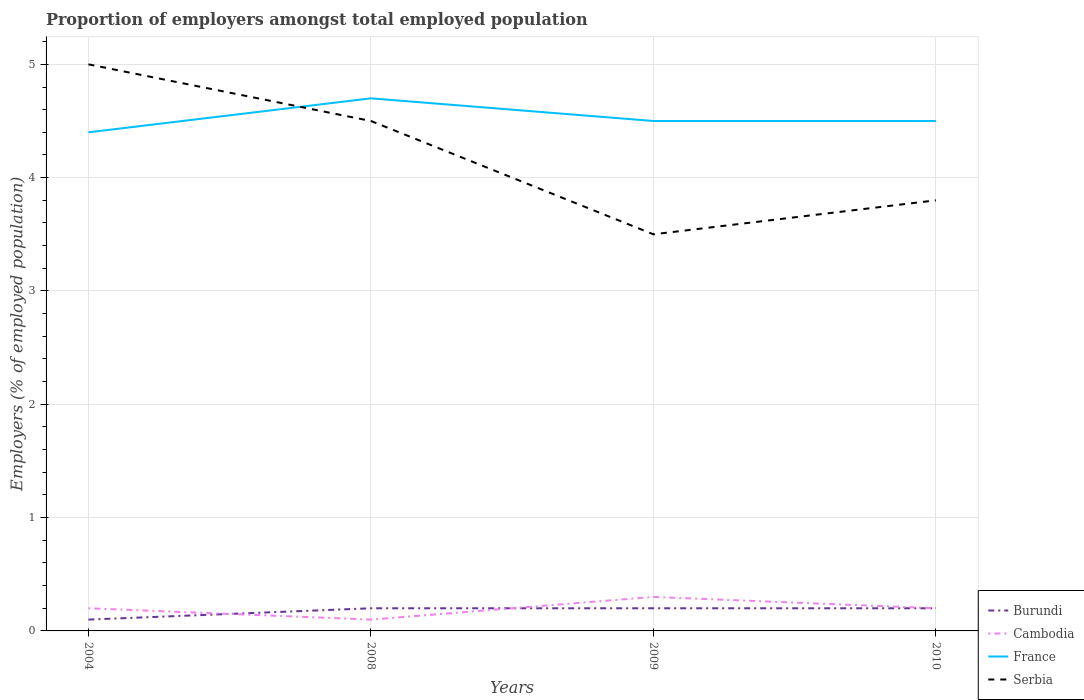What is the total proportion of employers in France in the graph?
Offer a very short reply. -0.1. How many lines are there?
Provide a short and direct response. 4. How many years are there in the graph?
Your answer should be very brief. 4. Are the values on the major ticks of Y-axis written in scientific E-notation?
Provide a short and direct response. No. How many legend labels are there?
Offer a terse response. 4. How are the legend labels stacked?
Provide a short and direct response. Vertical. What is the title of the graph?
Offer a very short reply. Proportion of employers amongst total employed population. Does "Bermuda" appear as one of the legend labels in the graph?
Provide a succinct answer. No. What is the label or title of the X-axis?
Offer a terse response. Years. What is the label or title of the Y-axis?
Provide a succinct answer. Employers (% of employed population). What is the Employers (% of employed population) of Burundi in 2004?
Provide a succinct answer. 0.1. What is the Employers (% of employed population) of Cambodia in 2004?
Ensure brevity in your answer.  0.2. What is the Employers (% of employed population) in France in 2004?
Ensure brevity in your answer.  4.4. What is the Employers (% of employed population) of Burundi in 2008?
Your answer should be compact. 0.2. What is the Employers (% of employed population) in Cambodia in 2008?
Your answer should be very brief. 0.1. What is the Employers (% of employed population) in France in 2008?
Make the answer very short. 4.7. What is the Employers (% of employed population) in Burundi in 2009?
Your response must be concise. 0.2. What is the Employers (% of employed population) of Cambodia in 2009?
Keep it short and to the point. 0.3. What is the Employers (% of employed population) of Burundi in 2010?
Your answer should be very brief. 0.2. What is the Employers (% of employed population) of Cambodia in 2010?
Give a very brief answer. 0.2. What is the Employers (% of employed population) in Serbia in 2010?
Your response must be concise. 3.8. Across all years, what is the maximum Employers (% of employed population) in Burundi?
Your answer should be very brief. 0.2. Across all years, what is the maximum Employers (% of employed population) of Cambodia?
Make the answer very short. 0.3. Across all years, what is the maximum Employers (% of employed population) in France?
Your response must be concise. 4.7. Across all years, what is the minimum Employers (% of employed population) of Burundi?
Your answer should be compact. 0.1. Across all years, what is the minimum Employers (% of employed population) in Cambodia?
Your answer should be compact. 0.1. Across all years, what is the minimum Employers (% of employed population) of France?
Ensure brevity in your answer.  4.4. What is the total Employers (% of employed population) of Cambodia in the graph?
Keep it short and to the point. 0.8. What is the total Employers (% of employed population) of France in the graph?
Provide a short and direct response. 18.1. What is the total Employers (% of employed population) in Serbia in the graph?
Ensure brevity in your answer.  16.8. What is the difference between the Employers (% of employed population) of Burundi in 2004 and that in 2008?
Keep it short and to the point. -0.1. What is the difference between the Employers (% of employed population) in Burundi in 2004 and that in 2009?
Provide a short and direct response. -0.1. What is the difference between the Employers (% of employed population) of France in 2004 and that in 2009?
Provide a succinct answer. -0.1. What is the difference between the Employers (% of employed population) in Cambodia in 2004 and that in 2010?
Give a very brief answer. 0. What is the difference between the Employers (% of employed population) of France in 2004 and that in 2010?
Your answer should be very brief. -0.1. What is the difference between the Employers (% of employed population) of Burundi in 2008 and that in 2009?
Your answer should be compact. 0. What is the difference between the Employers (% of employed population) of Cambodia in 2008 and that in 2009?
Provide a succinct answer. -0.2. What is the difference between the Employers (% of employed population) of Serbia in 2008 and that in 2010?
Ensure brevity in your answer.  0.7. What is the difference between the Employers (% of employed population) of Burundi in 2009 and that in 2010?
Provide a short and direct response. 0. What is the difference between the Employers (% of employed population) in France in 2009 and that in 2010?
Provide a succinct answer. 0. What is the difference between the Employers (% of employed population) in Burundi in 2004 and the Employers (% of employed population) in Cambodia in 2008?
Offer a terse response. 0. What is the difference between the Employers (% of employed population) in Burundi in 2004 and the Employers (% of employed population) in France in 2008?
Offer a very short reply. -4.6. What is the difference between the Employers (% of employed population) in Burundi in 2004 and the Employers (% of employed population) in Serbia in 2008?
Your response must be concise. -4.4. What is the difference between the Employers (% of employed population) in France in 2004 and the Employers (% of employed population) in Serbia in 2008?
Provide a succinct answer. -0.1. What is the difference between the Employers (% of employed population) in Burundi in 2004 and the Employers (% of employed population) in Serbia in 2009?
Your answer should be compact. -3.4. What is the difference between the Employers (% of employed population) in Cambodia in 2004 and the Employers (% of employed population) in Serbia in 2009?
Your response must be concise. -3.3. What is the difference between the Employers (% of employed population) in Burundi in 2004 and the Employers (% of employed population) in Cambodia in 2010?
Give a very brief answer. -0.1. What is the difference between the Employers (% of employed population) in Burundi in 2004 and the Employers (% of employed population) in France in 2010?
Ensure brevity in your answer.  -4.4. What is the difference between the Employers (% of employed population) in Burundi in 2004 and the Employers (% of employed population) in Serbia in 2010?
Your response must be concise. -3.7. What is the difference between the Employers (% of employed population) in Burundi in 2008 and the Employers (% of employed population) in France in 2009?
Your answer should be compact. -4.3. What is the difference between the Employers (% of employed population) of Cambodia in 2008 and the Employers (% of employed population) of France in 2009?
Keep it short and to the point. -4.4. What is the difference between the Employers (% of employed population) of Cambodia in 2008 and the Employers (% of employed population) of Serbia in 2009?
Offer a terse response. -3.4. What is the difference between the Employers (% of employed population) in Cambodia in 2008 and the Employers (% of employed population) in France in 2010?
Provide a succinct answer. -4.4. What is the difference between the Employers (% of employed population) in Cambodia in 2008 and the Employers (% of employed population) in Serbia in 2010?
Provide a short and direct response. -3.7. What is the difference between the Employers (% of employed population) of France in 2008 and the Employers (% of employed population) of Serbia in 2010?
Your answer should be compact. 0.9. What is the difference between the Employers (% of employed population) in Cambodia in 2009 and the Employers (% of employed population) in France in 2010?
Provide a succinct answer. -4.2. What is the difference between the Employers (% of employed population) of Cambodia in 2009 and the Employers (% of employed population) of Serbia in 2010?
Offer a terse response. -3.5. What is the average Employers (% of employed population) of Burundi per year?
Provide a short and direct response. 0.17. What is the average Employers (% of employed population) of France per year?
Your answer should be compact. 4.53. In the year 2004, what is the difference between the Employers (% of employed population) of Burundi and Employers (% of employed population) of Cambodia?
Give a very brief answer. -0.1. In the year 2004, what is the difference between the Employers (% of employed population) in Burundi and Employers (% of employed population) in France?
Give a very brief answer. -4.3. In the year 2004, what is the difference between the Employers (% of employed population) of Cambodia and Employers (% of employed population) of France?
Your answer should be compact. -4.2. In the year 2004, what is the difference between the Employers (% of employed population) of Cambodia and Employers (% of employed population) of Serbia?
Offer a terse response. -4.8. In the year 2008, what is the difference between the Employers (% of employed population) of Burundi and Employers (% of employed population) of Cambodia?
Provide a short and direct response. 0.1. In the year 2008, what is the difference between the Employers (% of employed population) in Burundi and Employers (% of employed population) in France?
Provide a succinct answer. -4.5. In the year 2008, what is the difference between the Employers (% of employed population) of France and Employers (% of employed population) of Serbia?
Your response must be concise. 0.2. In the year 2009, what is the difference between the Employers (% of employed population) of Burundi and Employers (% of employed population) of Cambodia?
Your answer should be very brief. -0.1. In the year 2009, what is the difference between the Employers (% of employed population) in Burundi and Employers (% of employed population) in France?
Provide a short and direct response. -4.3. In the year 2010, what is the difference between the Employers (% of employed population) in Burundi and Employers (% of employed population) in Cambodia?
Keep it short and to the point. 0. In the year 2010, what is the difference between the Employers (% of employed population) of Burundi and Employers (% of employed population) of France?
Keep it short and to the point. -4.3. In the year 2010, what is the difference between the Employers (% of employed population) in Cambodia and Employers (% of employed population) in France?
Your answer should be compact. -4.3. In the year 2010, what is the difference between the Employers (% of employed population) of France and Employers (% of employed population) of Serbia?
Keep it short and to the point. 0.7. What is the ratio of the Employers (% of employed population) of France in 2004 to that in 2008?
Offer a very short reply. 0.94. What is the ratio of the Employers (% of employed population) in Serbia in 2004 to that in 2008?
Provide a succinct answer. 1.11. What is the ratio of the Employers (% of employed population) in Cambodia in 2004 to that in 2009?
Offer a very short reply. 0.67. What is the ratio of the Employers (% of employed population) in France in 2004 to that in 2009?
Offer a very short reply. 0.98. What is the ratio of the Employers (% of employed population) in Serbia in 2004 to that in 2009?
Offer a terse response. 1.43. What is the ratio of the Employers (% of employed population) of Burundi in 2004 to that in 2010?
Keep it short and to the point. 0.5. What is the ratio of the Employers (% of employed population) of France in 2004 to that in 2010?
Your answer should be compact. 0.98. What is the ratio of the Employers (% of employed population) in Serbia in 2004 to that in 2010?
Provide a succinct answer. 1.32. What is the ratio of the Employers (% of employed population) of France in 2008 to that in 2009?
Ensure brevity in your answer.  1.04. What is the ratio of the Employers (% of employed population) in Burundi in 2008 to that in 2010?
Make the answer very short. 1. What is the ratio of the Employers (% of employed population) in Cambodia in 2008 to that in 2010?
Your answer should be compact. 0.5. What is the ratio of the Employers (% of employed population) in France in 2008 to that in 2010?
Provide a short and direct response. 1.04. What is the ratio of the Employers (% of employed population) of Serbia in 2008 to that in 2010?
Your answer should be compact. 1.18. What is the ratio of the Employers (% of employed population) of Serbia in 2009 to that in 2010?
Give a very brief answer. 0.92. What is the difference between the highest and the second highest Employers (% of employed population) of Burundi?
Give a very brief answer. 0. What is the difference between the highest and the second highest Employers (% of employed population) of France?
Your answer should be very brief. 0.2. What is the difference between the highest and the lowest Employers (% of employed population) in Burundi?
Offer a very short reply. 0.1. What is the difference between the highest and the lowest Employers (% of employed population) in Cambodia?
Offer a terse response. 0.2. What is the difference between the highest and the lowest Employers (% of employed population) in Serbia?
Your answer should be very brief. 1.5. 